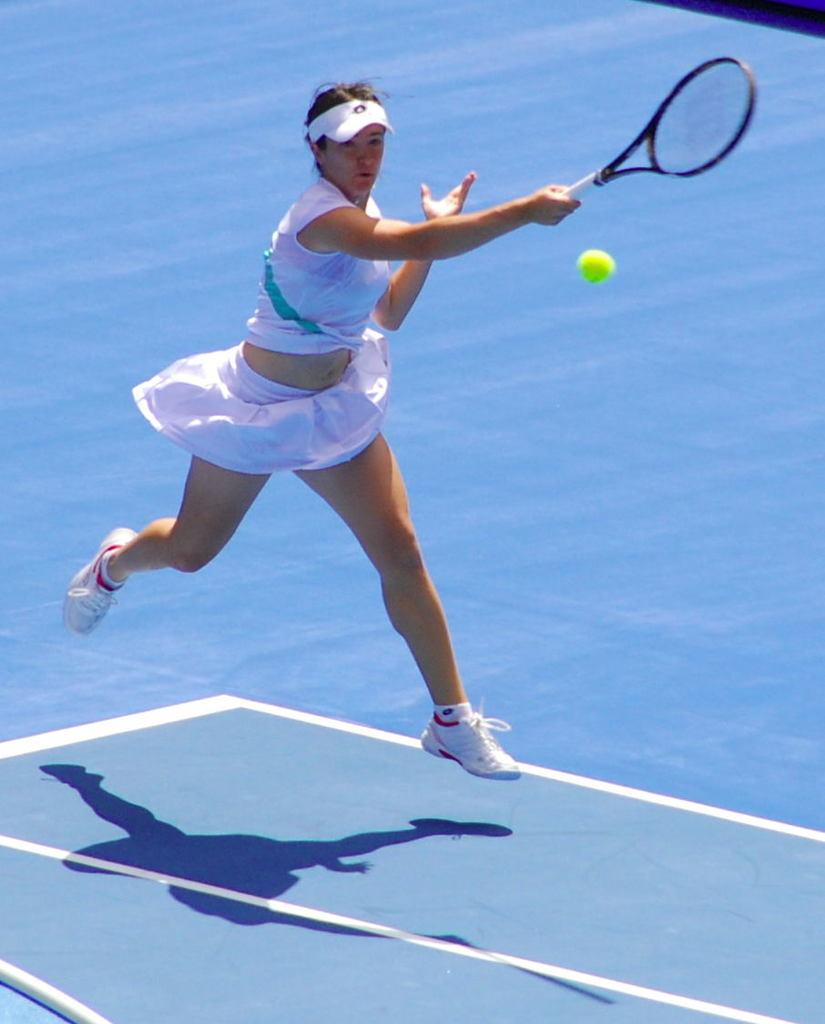Who is the main subject in the image? There is a woman in the image. What is the woman doing in the image? The woman is playing badminton. Where is the woman playing badminton? The woman is playing in a court. What type of song is the giraffe singing in the image? There is no giraffe or song present in the image. 